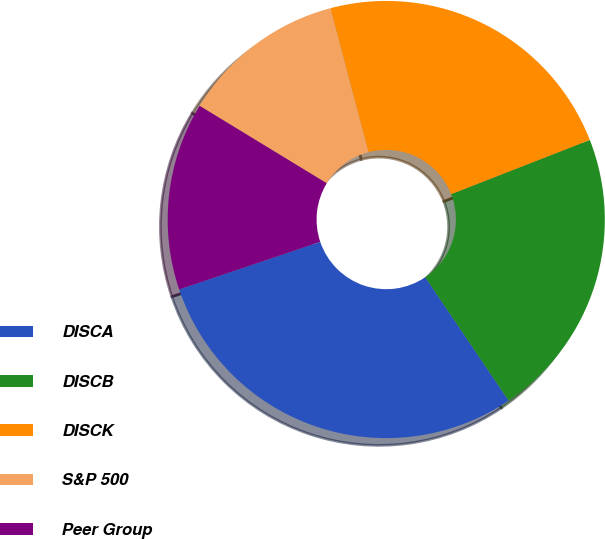Convert chart. <chart><loc_0><loc_0><loc_500><loc_500><pie_chart><fcel>DISCA<fcel>DISCB<fcel>DISCK<fcel>S&P 500<fcel>Peer Group<nl><fcel>29.28%<fcel>21.47%<fcel>23.18%<fcel>12.18%<fcel>13.89%<nl></chart> 